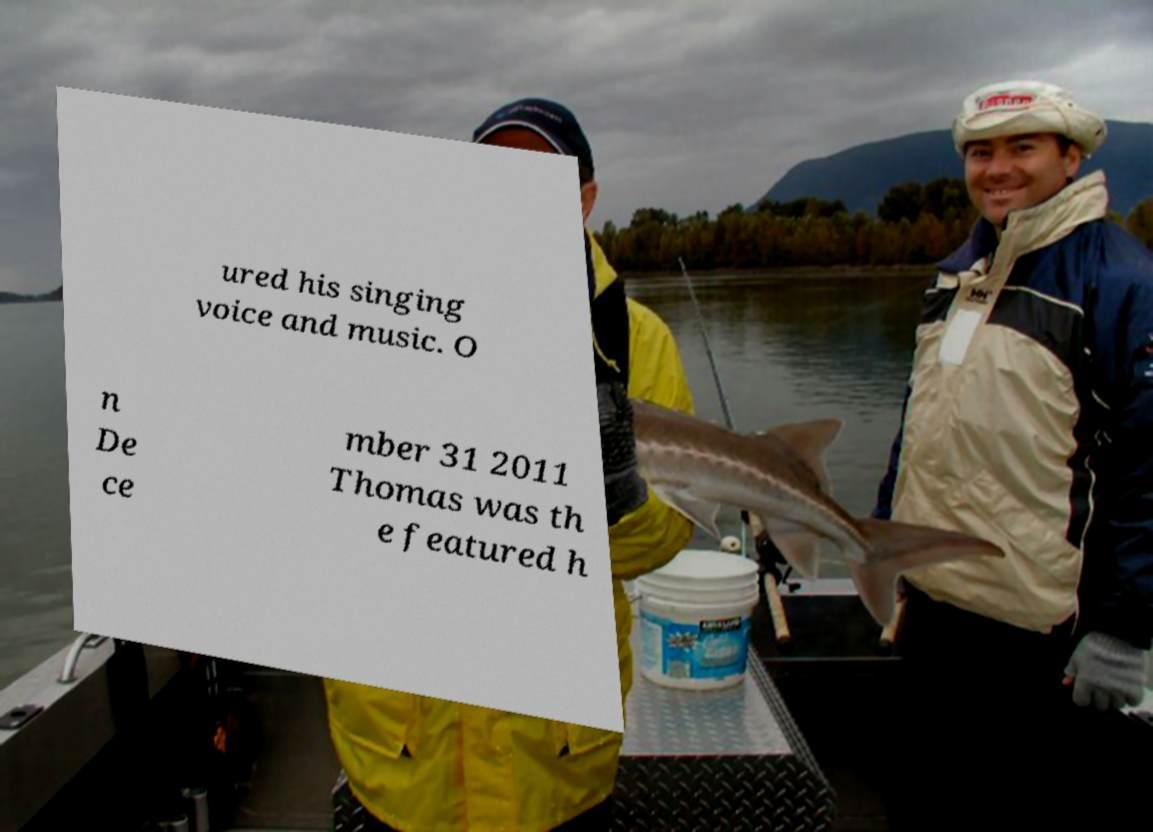Could you assist in decoding the text presented in this image and type it out clearly? ured his singing voice and music. O n De ce mber 31 2011 Thomas was th e featured h 